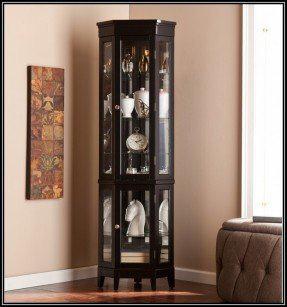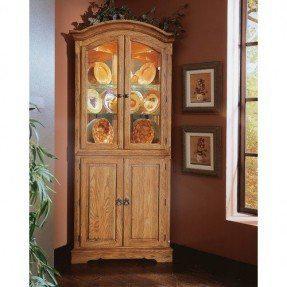The first image is the image on the left, the second image is the image on the right. For the images shown, is this caption "a picture frame is visible on the right image." true? Answer yes or no. Yes. 